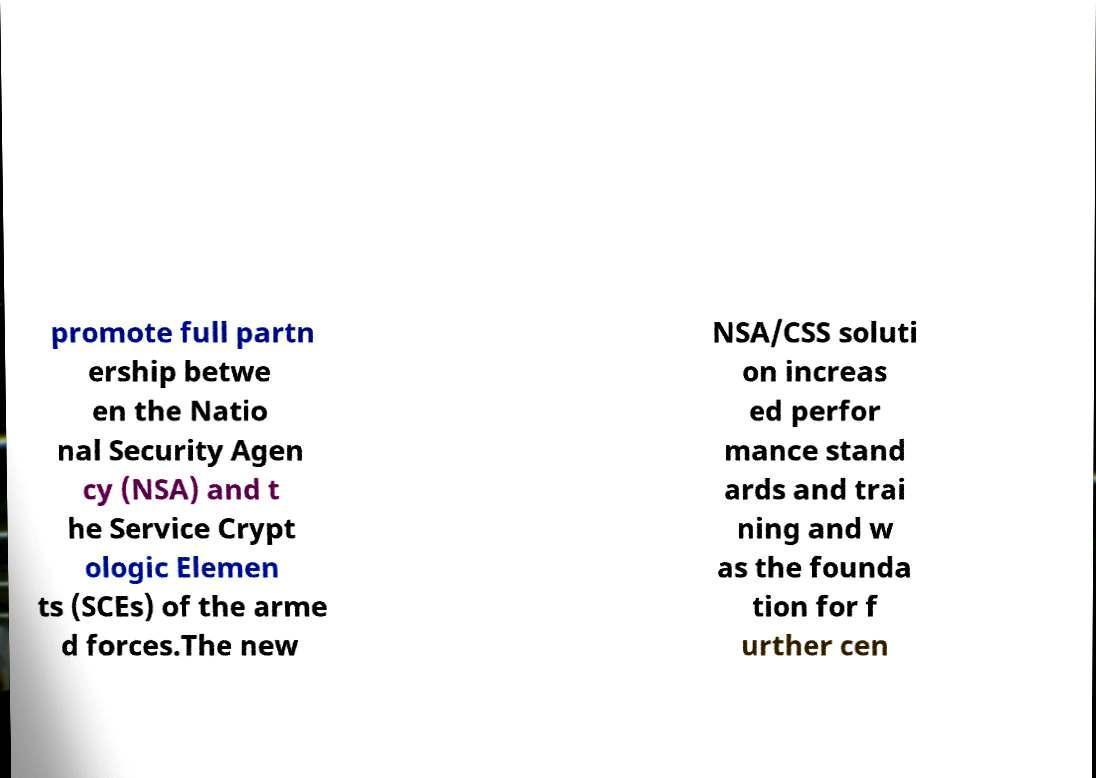Can you read and provide the text displayed in the image?This photo seems to have some interesting text. Can you extract and type it out for me? promote full partn ership betwe en the Natio nal Security Agen cy (NSA) and t he Service Crypt ologic Elemen ts (SCEs) of the arme d forces.The new NSA/CSS soluti on increas ed perfor mance stand ards and trai ning and w as the founda tion for f urther cen 